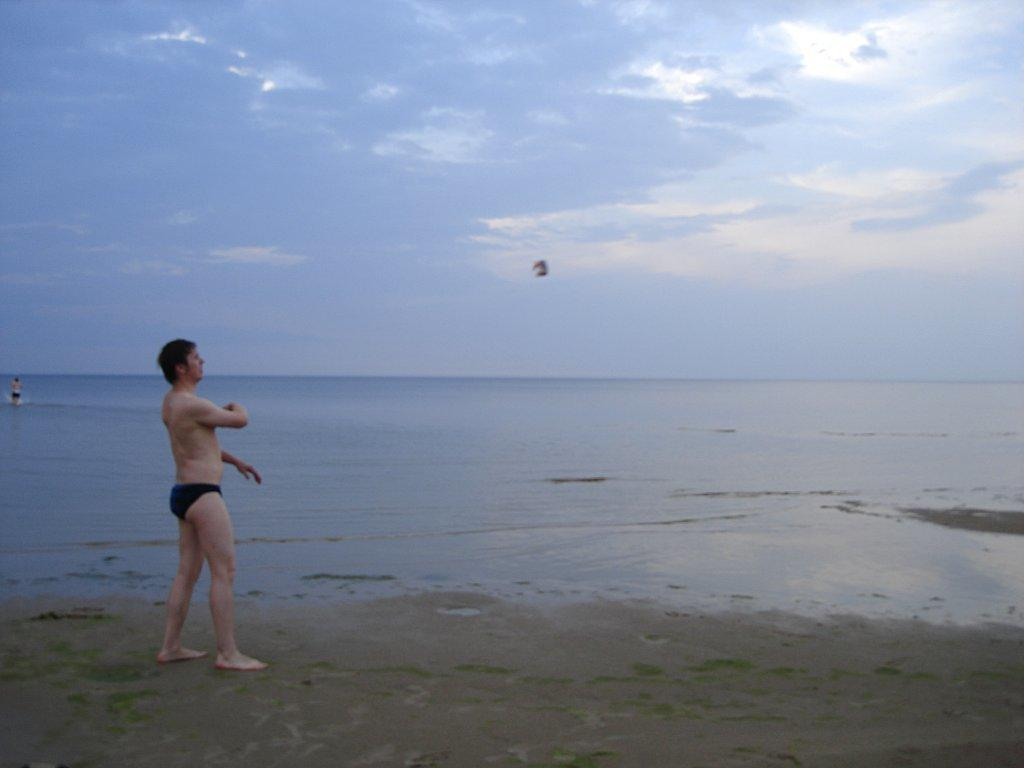What is the primary location of the person in the foreground of the image? There is a person standing on the ground in the image. Can you describe the person in the background of the image? There is a person in the water in the background of the image. What can be seen in the sky in the image? The sky is visible in the background of the image. What type of map can be seen on the person's bed in the image? There is no map or bed present in the image. 